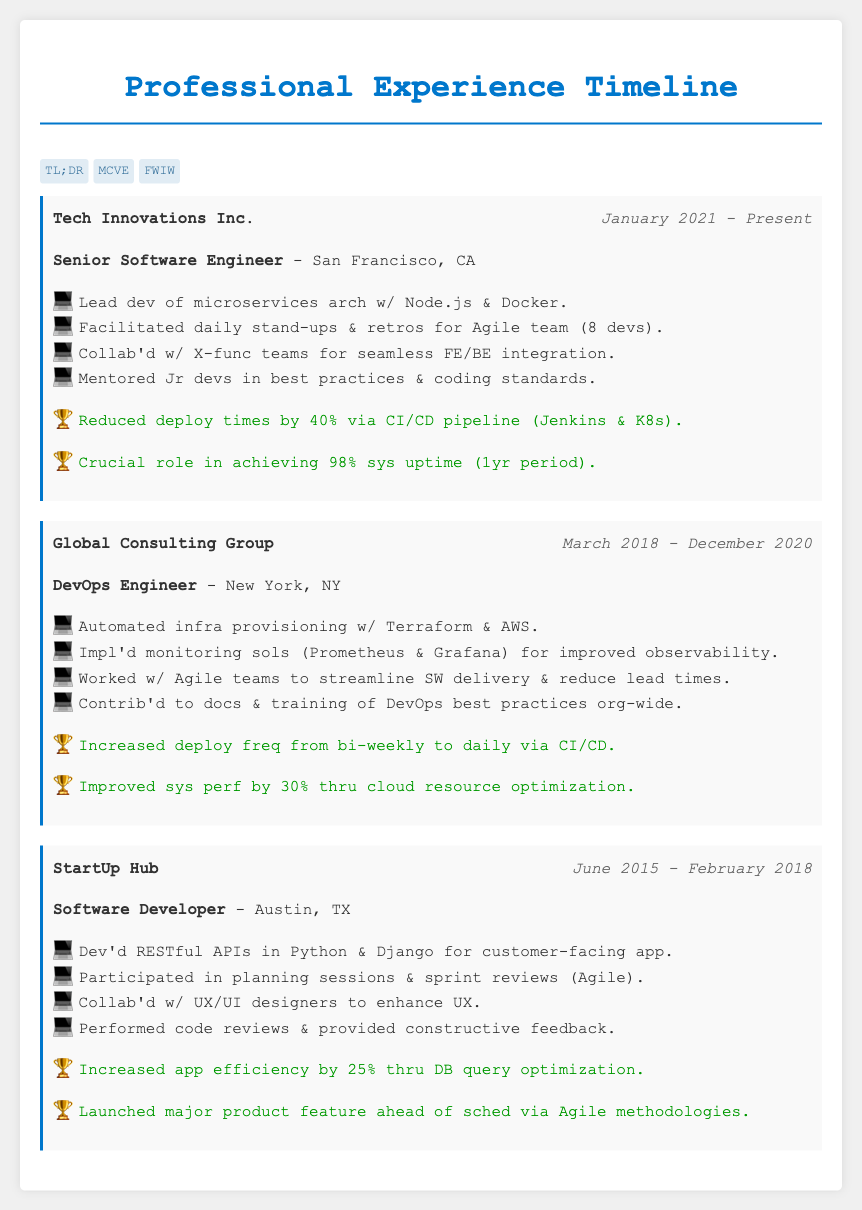What is the current role held at Tech Innovations Inc.? The document states that the individual is a Senior Software Engineer at Tech Innovations Inc.
Answer: Senior Software Engineer When did the individual start working at Global Consulting Group? The timeline shows that the individual began working at Global Consulting Group in March 2018.
Answer: March 2018 How much was the deploy frequency increased at Global Consulting Group? The document indicates that the deploy frequency increased from bi-weekly to daily.
Answer: Daily What was an achievement during the time at StartUp Hub? The document notes that an achievement included launching a major product feature ahead of schedule via Agile methodologies.
Answer: Launched major product feature ahead of schedule Which technology was used for monitoring solutions at Global Consulting Group? According to the document, Prometheus and Grafana were implemented for monitoring solutions.
Answer: Prometheus & Grafana How many developers were in the Agile team at Tech Innovations Inc.? The document specifies that the Agile team consisted of 8 developers.
Answer: 8 devs 